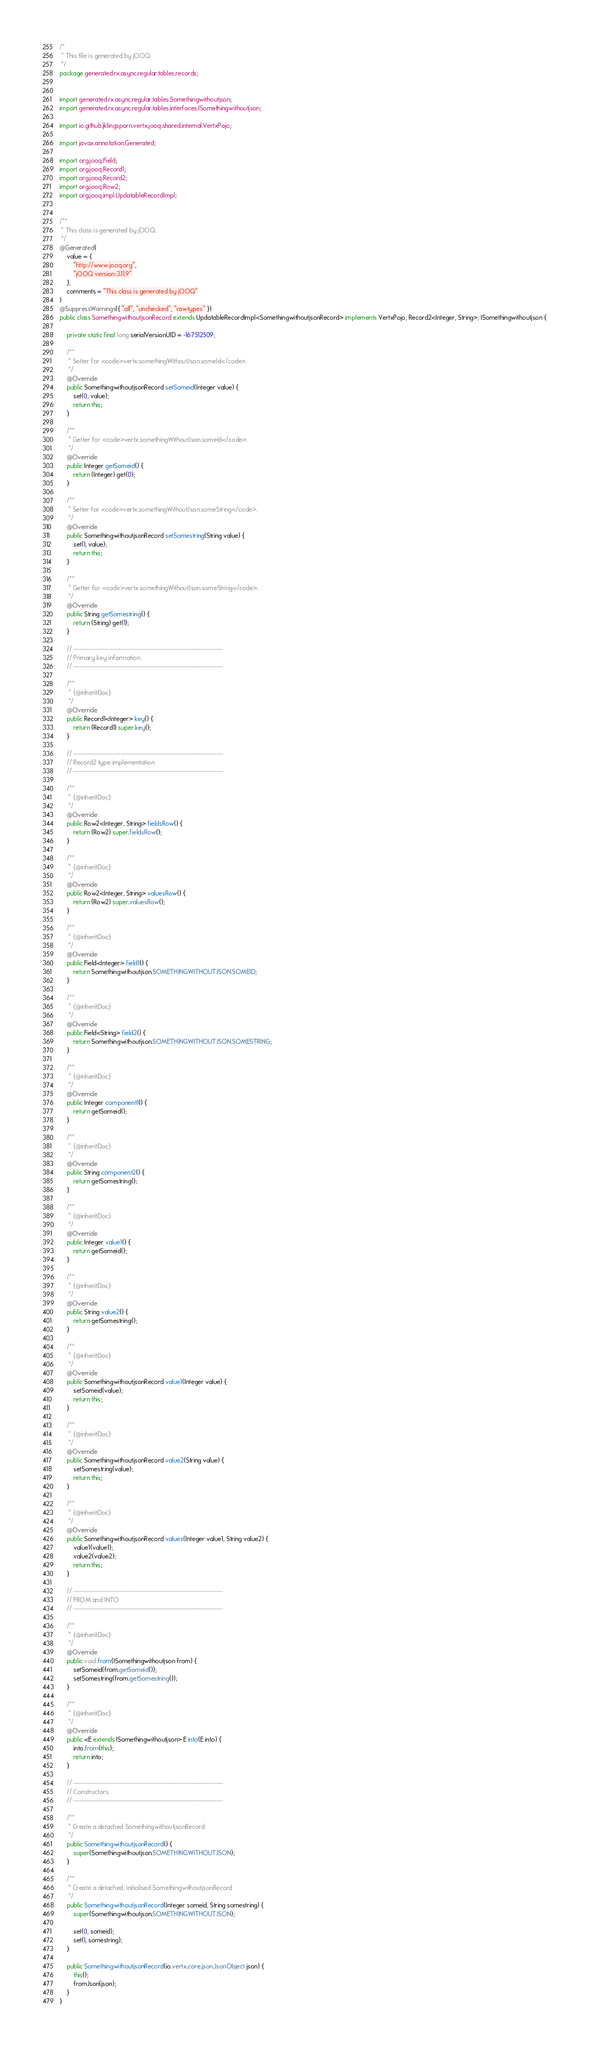<code> <loc_0><loc_0><loc_500><loc_500><_Java_>/*
 * This file is generated by jOOQ.
 */
package generated.rx.async.regular.tables.records;


import generated.rx.async.regular.tables.Somethingwithoutjson;
import generated.rx.async.regular.tables.interfaces.ISomethingwithoutjson;

import io.github.jklingsporn.vertx.jooq.shared.internal.VertxPojo;

import javax.annotation.Generated;

import org.jooq.Field;
import org.jooq.Record1;
import org.jooq.Record2;
import org.jooq.Row2;
import org.jooq.impl.UpdatableRecordImpl;


/**
 * This class is generated by jOOQ.
 */
@Generated(
    value = {
        "http://www.jooq.org",
        "jOOQ version:3.11.9"
    },
    comments = "This class is generated by jOOQ"
)
@SuppressWarnings({ "all", "unchecked", "rawtypes" })
public class SomethingwithoutjsonRecord extends UpdatableRecordImpl<SomethingwithoutjsonRecord> implements VertxPojo, Record2<Integer, String>, ISomethingwithoutjson {

    private static final long serialVersionUID = -167512509;

    /**
     * Setter for <code>vertx.somethingWithoutJson.someId</code>.
     */
    @Override
    public SomethingwithoutjsonRecord setSomeid(Integer value) {
        set(0, value);
        return this;
    }

    /**
     * Getter for <code>vertx.somethingWithoutJson.someId</code>.
     */
    @Override
    public Integer getSomeid() {
        return (Integer) get(0);
    }

    /**
     * Setter for <code>vertx.somethingWithoutJson.someString</code>.
     */
    @Override
    public SomethingwithoutjsonRecord setSomestring(String value) {
        set(1, value);
        return this;
    }

    /**
     * Getter for <code>vertx.somethingWithoutJson.someString</code>.
     */
    @Override
    public String getSomestring() {
        return (String) get(1);
    }

    // -------------------------------------------------------------------------
    // Primary key information
    // -------------------------------------------------------------------------

    /**
     * {@inheritDoc}
     */
    @Override
    public Record1<Integer> key() {
        return (Record1) super.key();
    }

    // -------------------------------------------------------------------------
    // Record2 type implementation
    // -------------------------------------------------------------------------

    /**
     * {@inheritDoc}
     */
    @Override
    public Row2<Integer, String> fieldsRow() {
        return (Row2) super.fieldsRow();
    }

    /**
     * {@inheritDoc}
     */
    @Override
    public Row2<Integer, String> valuesRow() {
        return (Row2) super.valuesRow();
    }

    /**
     * {@inheritDoc}
     */
    @Override
    public Field<Integer> field1() {
        return Somethingwithoutjson.SOMETHINGWITHOUTJSON.SOMEID;
    }

    /**
     * {@inheritDoc}
     */
    @Override
    public Field<String> field2() {
        return Somethingwithoutjson.SOMETHINGWITHOUTJSON.SOMESTRING;
    }

    /**
     * {@inheritDoc}
     */
    @Override
    public Integer component1() {
        return getSomeid();
    }

    /**
     * {@inheritDoc}
     */
    @Override
    public String component2() {
        return getSomestring();
    }

    /**
     * {@inheritDoc}
     */
    @Override
    public Integer value1() {
        return getSomeid();
    }

    /**
     * {@inheritDoc}
     */
    @Override
    public String value2() {
        return getSomestring();
    }

    /**
     * {@inheritDoc}
     */
    @Override
    public SomethingwithoutjsonRecord value1(Integer value) {
        setSomeid(value);
        return this;
    }

    /**
     * {@inheritDoc}
     */
    @Override
    public SomethingwithoutjsonRecord value2(String value) {
        setSomestring(value);
        return this;
    }

    /**
     * {@inheritDoc}
     */
    @Override
    public SomethingwithoutjsonRecord values(Integer value1, String value2) {
        value1(value1);
        value2(value2);
        return this;
    }

    // -------------------------------------------------------------------------
    // FROM and INTO
    // -------------------------------------------------------------------------

    /**
     * {@inheritDoc}
     */
    @Override
    public void from(ISomethingwithoutjson from) {
        setSomeid(from.getSomeid());
        setSomestring(from.getSomestring());
    }

    /**
     * {@inheritDoc}
     */
    @Override
    public <E extends ISomethingwithoutjson> E into(E into) {
        into.from(this);
        return into;
    }

    // -------------------------------------------------------------------------
    // Constructors
    // -------------------------------------------------------------------------

    /**
     * Create a detached SomethingwithoutjsonRecord
     */
    public SomethingwithoutjsonRecord() {
        super(Somethingwithoutjson.SOMETHINGWITHOUTJSON);
    }

    /**
     * Create a detached, initialised SomethingwithoutjsonRecord
     */
    public SomethingwithoutjsonRecord(Integer someid, String somestring) {
        super(Somethingwithoutjson.SOMETHINGWITHOUTJSON);

        set(0, someid);
        set(1, somestring);
    }

    public SomethingwithoutjsonRecord(io.vertx.core.json.JsonObject json) {
        this();
        fromJson(json);
    }
}
</code> 